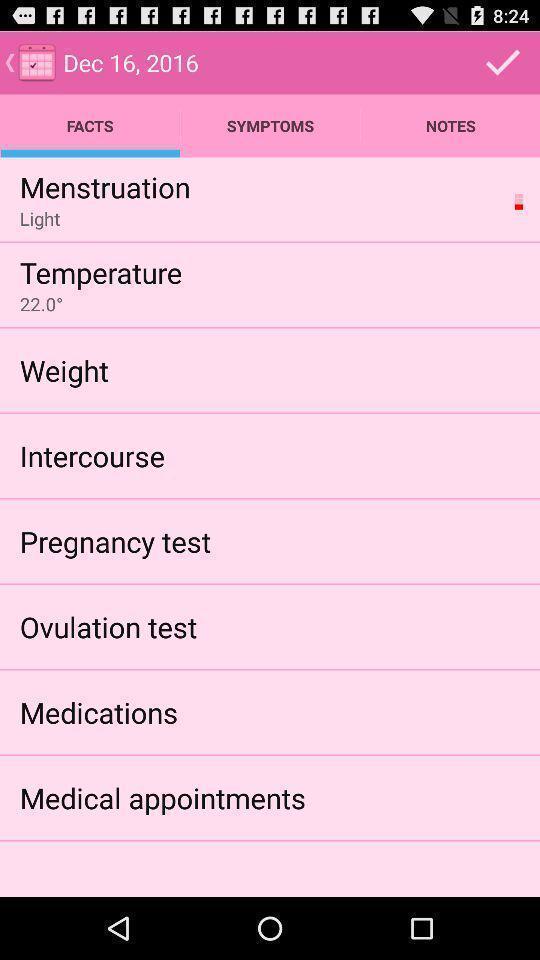What details can you identify in this image? List of facts for different situations in a healthcare application. 